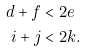Convert formula to latex. <formula><loc_0><loc_0><loc_500><loc_500>d + f & < 2 e \\ i + j & < 2 k .</formula> 